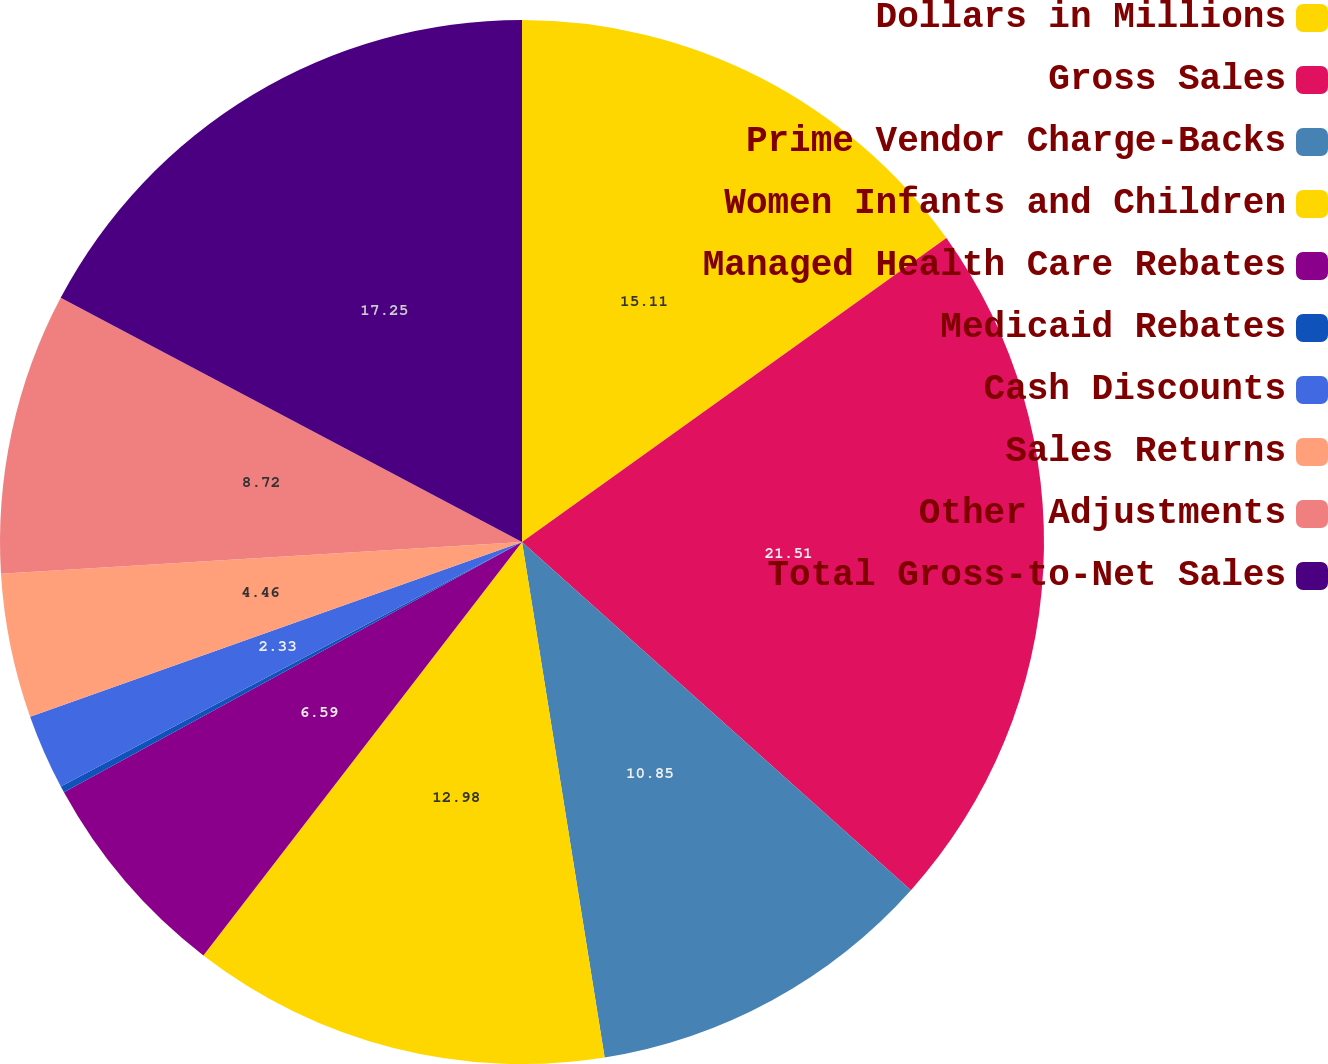Convert chart to OTSL. <chart><loc_0><loc_0><loc_500><loc_500><pie_chart><fcel>Dollars in Millions<fcel>Gross Sales<fcel>Prime Vendor Charge-Backs<fcel>Women Infants and Children<fcel>Managed Health Care Rebates<fcel>Medicaid Rebates<fcel>Cash Discounts<fcel>Sales Returns<fcel>Other Adjustments<fcel>Total Gross-to-Net Sales<nl><fcel>15.11%<fcel>21.51%<fcel>10.85%<fcel>12.98%<fcel>6.59%<fcel>0.2%<fcel>2.33%<fcel>4.46%<fcel>8.72%<fcel>17.25%<nl></chart> 